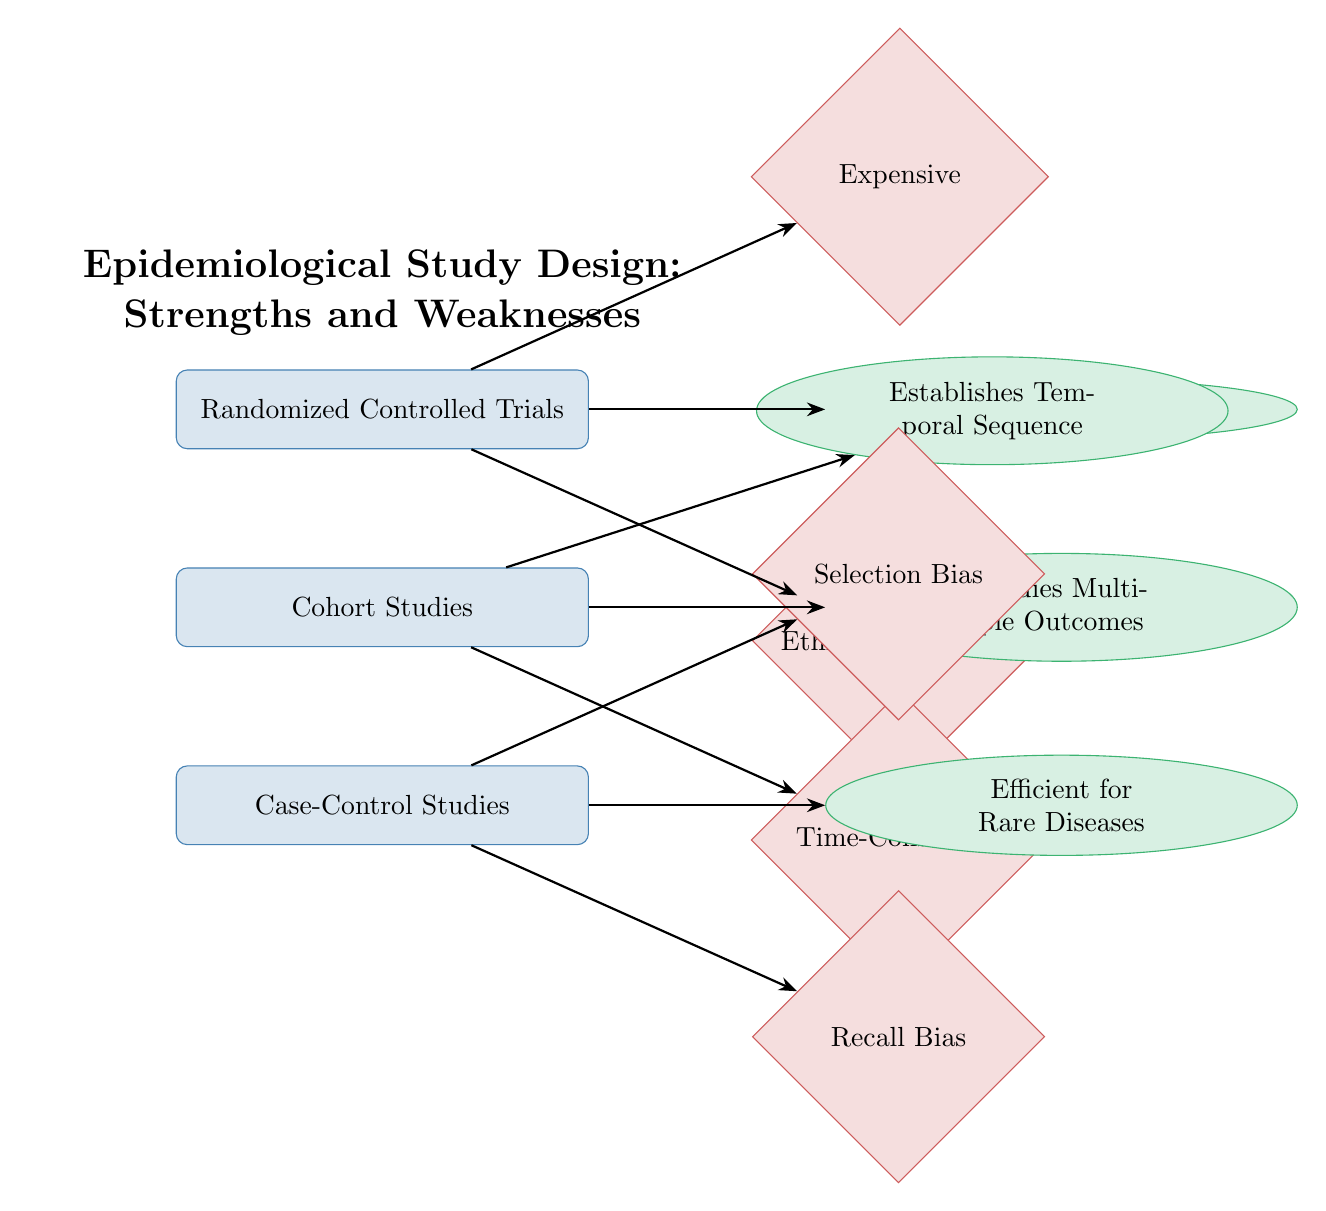What study type is located at the top of the diagram? The diagram shows three study types: Randomized Controlled Trials, Cohort Studies, and Case-Control Studies. The first one listed at the top is "Randomized Controlled Trials."
Answer: Randomized Controlled Trials What are the strengths associated with Cohort Studies? According to the diagram, Cohort Studies have two strengths listed: "Establishes Temporal Sequence" and "Studies Multiple Outcomes."
Answer: Establishes Temporal Sequence; Studies Multiple Outcomes How many weaknesses are listed for Case-Control Studies? The diagram specifies three weaknesses associated with Case-Control Studies: "Selection Bias" and "Recall Bias." Counting these gives a total of two weaknesses.
Answer: 2 Which type of study is noted as expensive? The diagram indicates that the weakness related to "Expensive" is linked to Randomized Controlled Trials, thus identifying this study type as having that characteristic.
Answer: Randomized Controlled Trials What is the main strength of Case-Control Studies? The diagram highlights "Efficient for Rare Diseases" as the key strength associated with Case-Control Studies.
Answer: Efficient for Rare Diseases What is the relationship between strengths and weaknesses of RCTs in the diagram? The diagram shows that Randomized Controlled Trials have one strength ("High Internal Validity") linked to them, while two weaknesses ("Expensive" and "Ethical Constraints") are also associated, indicating a balance of factors.
Answer: One strength, two weaknesses Which study type is described as time-consuming? The weakness "Time-Consuming" is explicitly linked to Cohort Studies, indicating that this particular study type is characterized by that limitation.
Answer: Cohort Studies What is the color used to represent strengths in this diagram? The diagram uses an ellipse shape filled with a light green color for strengths, specifically identified with the color code given as "strengthcolor". Hence, the associated color for strengths is green.
Answer: Green 